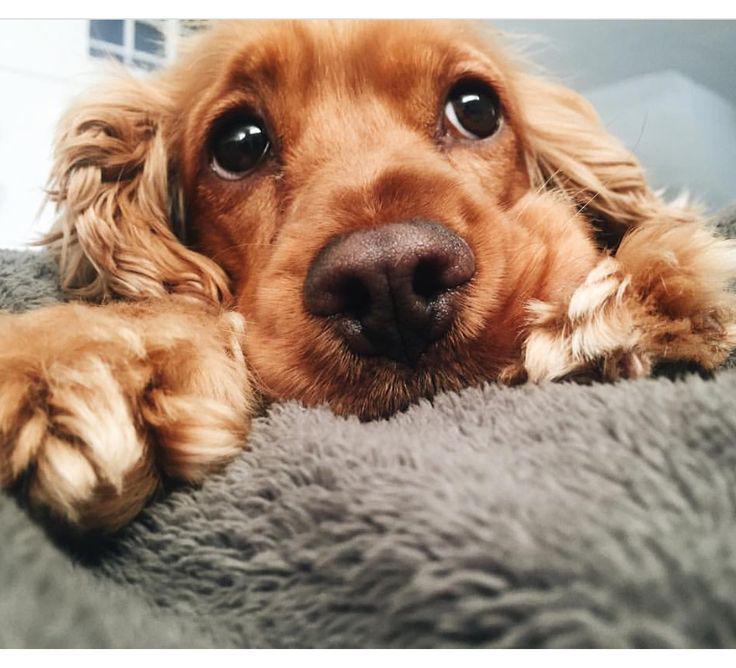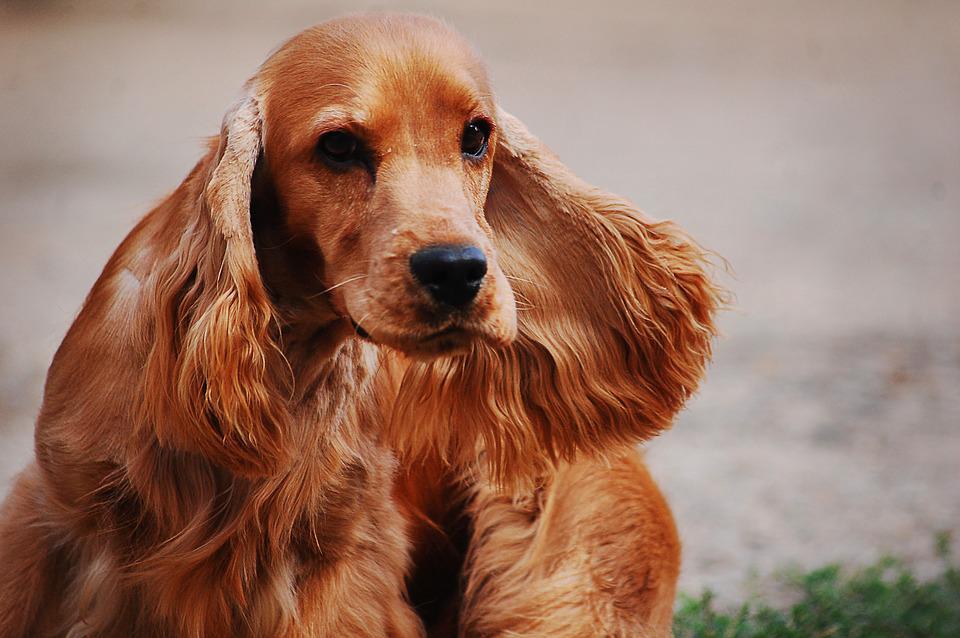The first image is the image on the left, the second image is the image on the right. Analyze the images presented: Is the assertion "The dog in the image on the left is lying on a grey material." valid? Answer yes or no. Yes. The first image is the image on the left, the second image is the image on the right. Evaluate the accuracy of this statement regarding the images: "An image shows one dog with its head resting on some type of grey soft surface.". Is it true? Answer yes or no. Yes. 